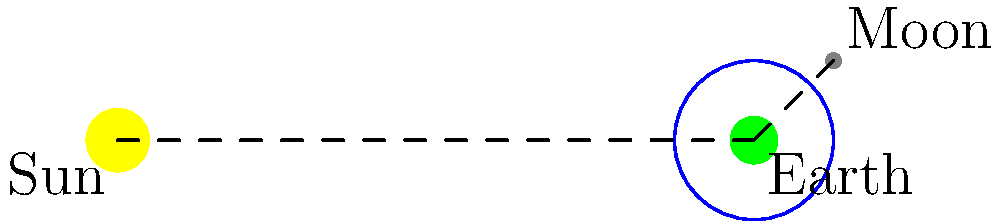As a Node.js developer working on an astronomy application that processes celestial data, you need to implement a function to determine the Moon's phase based on its position relative to the Earth and Sun. Given the diagram showing the positions of the Sun, Earth, and Moon, what phase of the Moon would be visible from Earth? To determine the Moon's phase, we need to consider the relative positions of the Sun, Earth, and Moon:

1. The Sun illuminates half of the Moon's surface at all times.
2. The phase we see from Earth depends on how much of the illuminated half is visible to us.
3. In this diagram, the Moon is positioned slightly to the right and above the Earth when viewed from the Sun.
4. This means that from Earth's perspective, we can see most of the illuminated half of the Moon, but not quite all of it.
5. The illuminated portion is on the right side of the Moon as seen from Earth.
6. When more than half but not all of the Moon's illuminated surface is visible, with the right side fully lit, it's called a Gibbous phase.
7. Specifically, this is a Waxing Gibbous phase because the illuminated portion is increasing (waxing) day by day.

In your Node.js application, you would need to implement logic that calculates the angle between the Sun-Earth line and the Earth-Moon line. For a Waxing Gibbous phase, this angle would typically be between about 135° and 180°.
Answer: Waxing Gibbous 